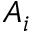Convert formula to latex. <formula><loc_0><loc_0><loc_500><loc_500>A _ { i }</formula> 